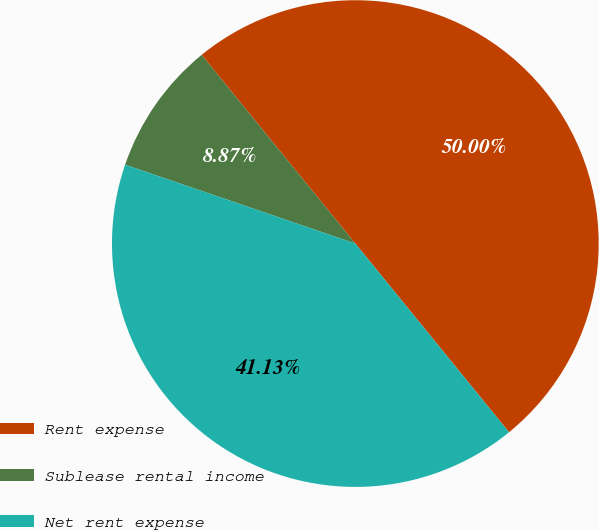Convert chart. <chart><loc_0><loc_0><loc_500><loc_500><pie_chart><fcel>Rent expense<fcel>Sublease rental income<fcel>Net rent expense<nl><fcel>50.0%<fcel>8.87%<fcel>41.13%<nl></chart> 